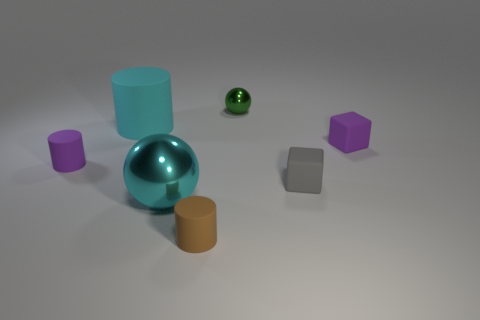How many other objects are the same size as the gray rubber object?
Make the answer very short. 4. Does the big object on the right side of the big cyan rubber cylinder have the same shape as the green thing?
Your response must be concise. Yes. There is another shiny thing that is the same shape as the tiny green object; what is its color?
Your answer should be compact. Cyan. Is the number of purple rubber cylinders behind the purple cube the same as the number of purple cubes?
Provide a succinct answer. No. What number of things are both on the left side of the tiny green object and in front of the large matte thing?
Keep it short and to the point. 3. What size is the purple rubber object that is the same shape as the brown thing?
Your response must be concise. Small. How many purple blocks are made of the same material as the green sphere?
Ensure brevity in your answer.  0. Is the number of tiny things left of the purple rubber cube less than the number of small things?
Make the answer very short. Yes. What number of yellow metallic balls are there?
Provide a succinct answer. 0. What number of large matte things are the same color as the tiny shiny thing?
Make the answer very short. 0. 